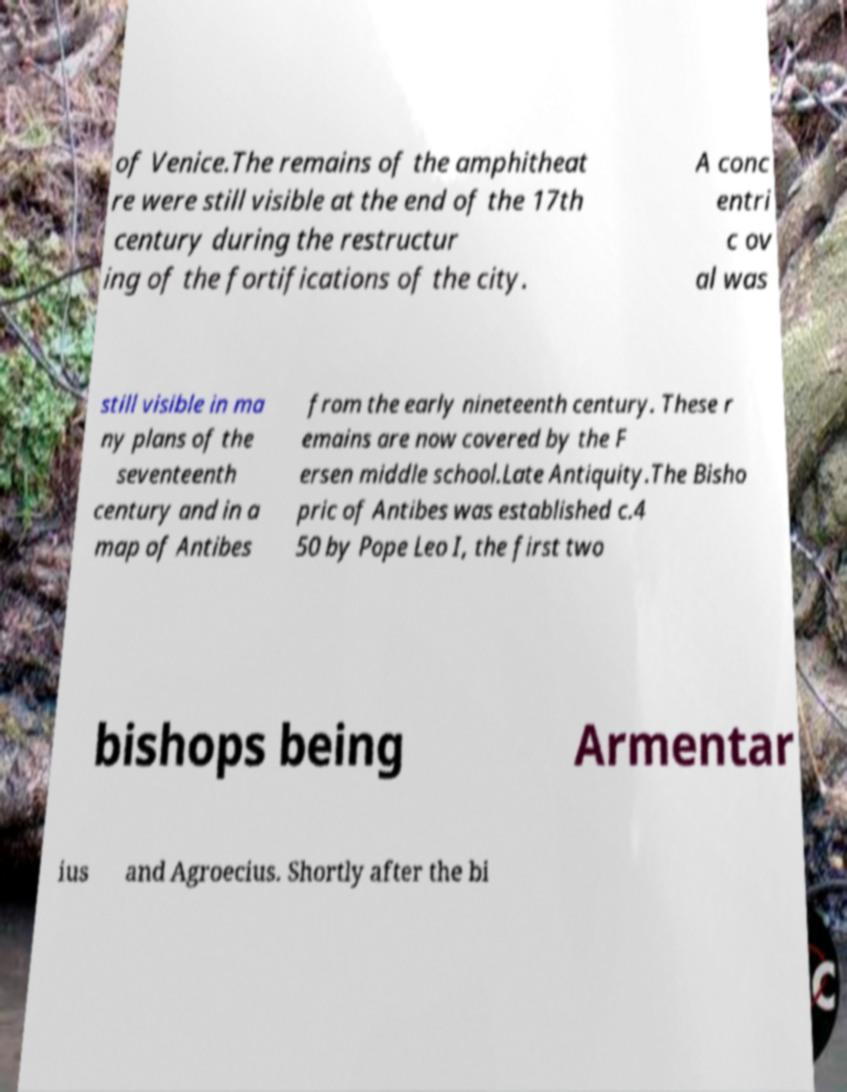For documentation purposes, I need the text within this image transcribed. Could you provide that? of Venice.The remains of the amphitheat re were still visible at the end of the 17th century during the restructur ing of the fortifications of the city. A conc entri c ov al was still visible in ma ny plans of the seventeenth century and in a map of Antibes from the early nineteenth century. These r emains are now covered by the F ersen middle school.Late Antiquity.The Bisho pric of Antibes was established c.4 50 by Pope Leo I, the first two bishops being Armentar ius and Agroecius. Shortly after the bi 